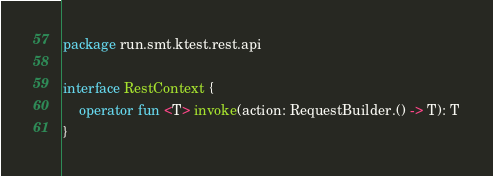Convert code to text. <code><loc_0><loc_0><loc_500><loc_500><_Kotlin_>package run.smt.ktest.rest.api

interface RestContext {
    operator fun <T> invoke(action: RequestBuilder.() -> T): T
}
</code> 